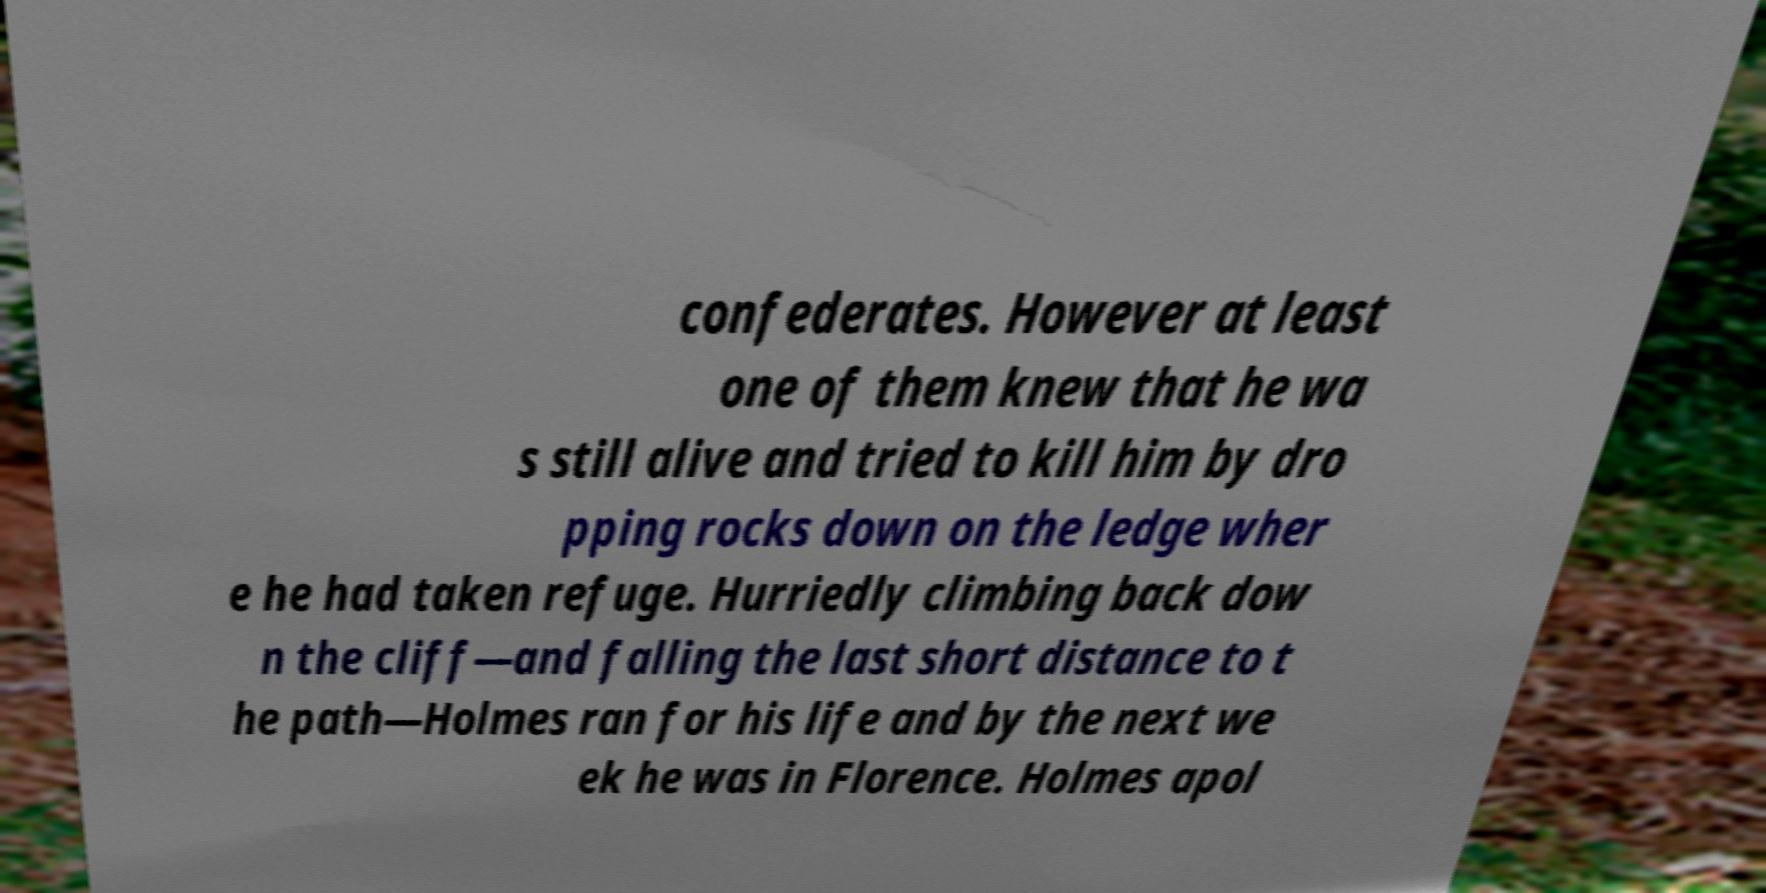Please identify and transcribe the text found in this image. confederates. However at least one of them knew that he wa s still alive and tried to kill him by dro pping rocks down on the ledge wher e he had taken refuge. Hurriedly climbing back dow n the cliff—and falling the last short distance to t he path—Holmes ran for his life and by the next we ek he was in Florence. Holmes apol 